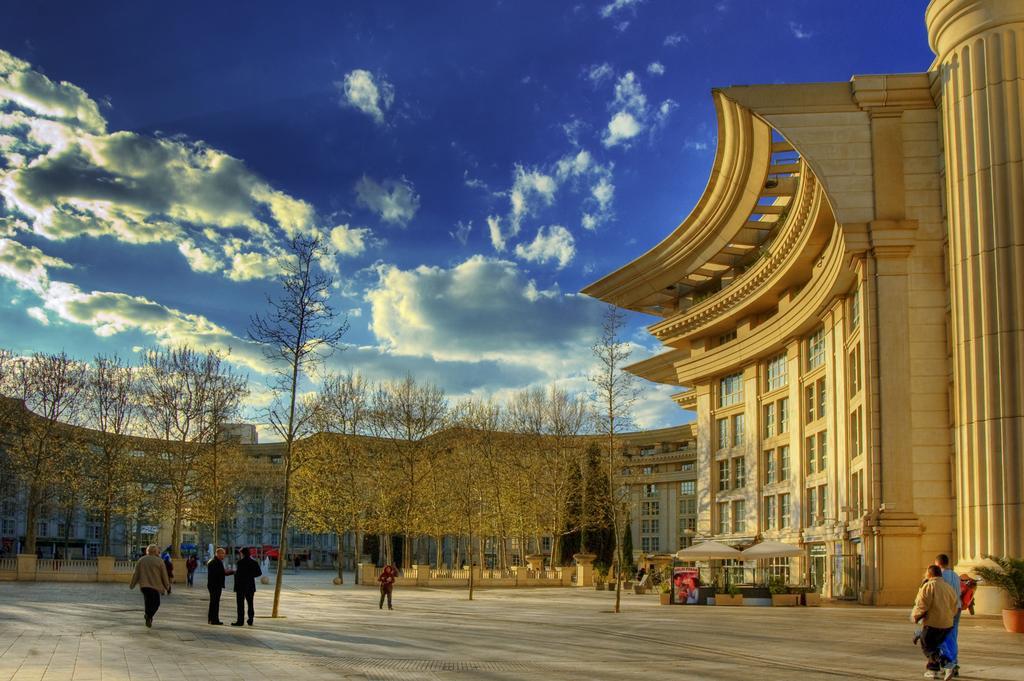Describe this image in one or two sentences. This is an outside view. At the bottom of the image I can see few people are standing and few people are walking on the ground. On the right side, I can see a building along with the windows and a pillar. In the background there are many trees and buildings. At the top, I can see the sky and clouds. 